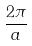<formula> <loc_0><loc_0><loc_500><loc_500>\frac { 2 \pi } { a }</formula> 